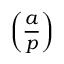<formula> <loc_0><loc_0><loc_500><loc_500>\left ( { \frac { a } { p } } \right )</formula> 